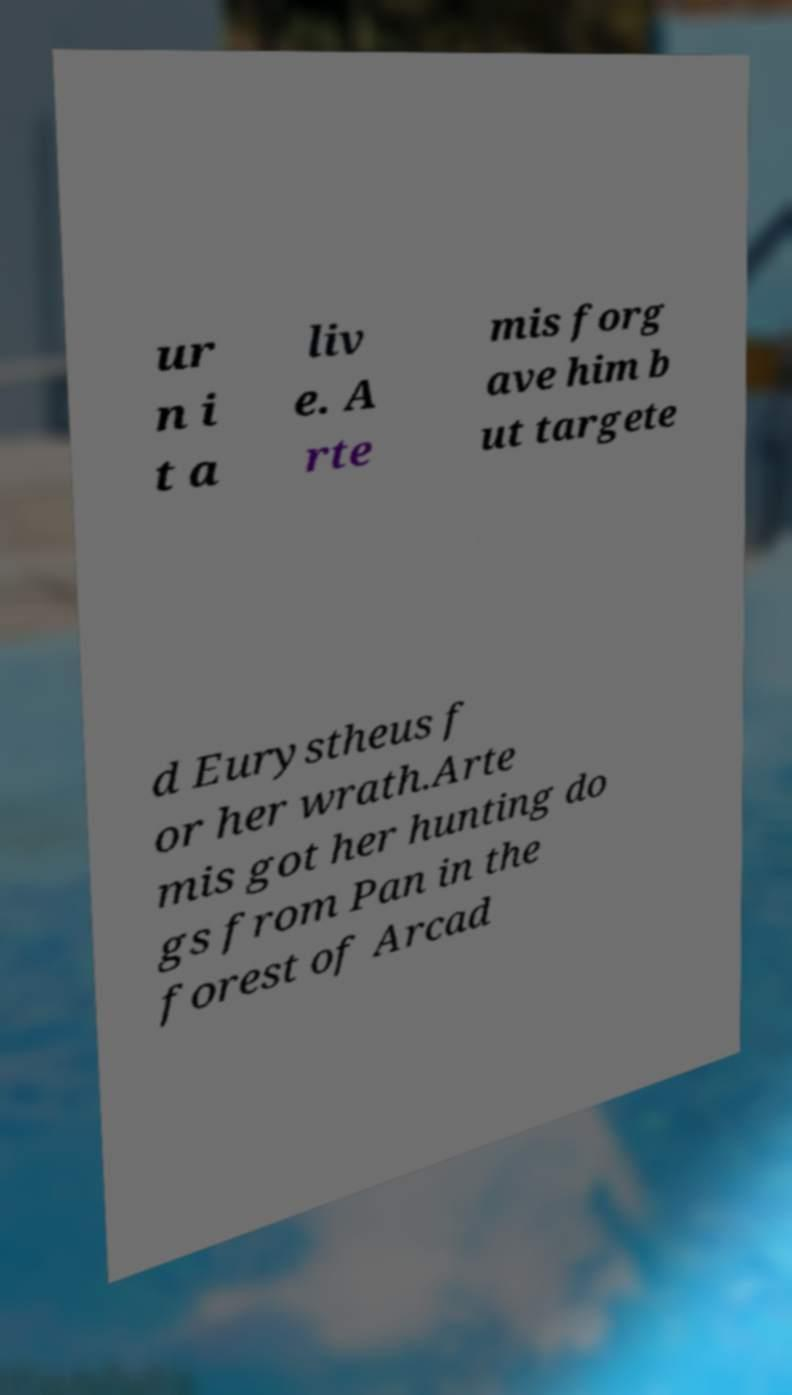Could you assist in decoding the text presented in this image and type it out clearly? ur n i t a liv e. A rte mis forg ave him b ut targete d Eurystheus f or her wrath.Arte mis got her hunting do gs from Pan in the forest of Arcad 